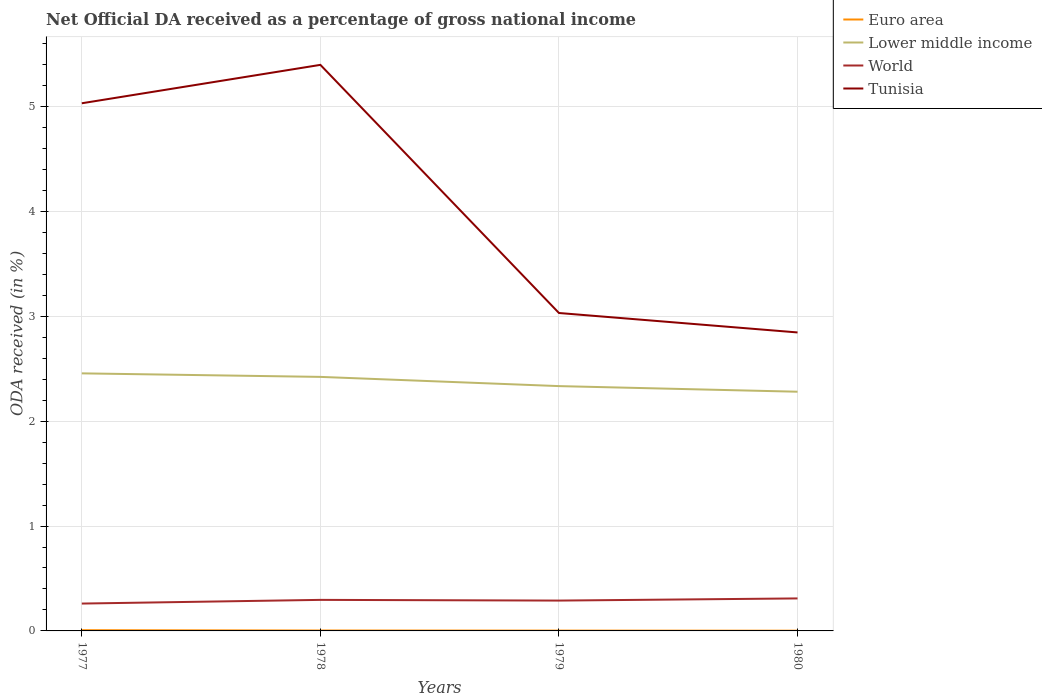Does the line corresponding to Lower middle income intersect with the line corresponding to World?
Your answer should be very brief. No. Is the number of lines equal to the number of legend labels?
Your answer should be very brief. Yes. Across all years, what is the maximum net official DA received in Euro area?
Ensure brevity in your answer.  0. In which year was the net official DA received in Lower middle income maximum?
Offer a terse response. 1980. What is the total net official DA received in Euro area in the graph?
Offer a very short reply. 0. What is the difference between the highest and the second highest net official DA received in Euro area?
Your answer should be very brief. 0. What is the difference between the highest and the lowest net official DA received in Lower middle income?
Offer a very short reply. 2. Is the net official DA received in Tunisia strictly greater than the net official DA received in Euro area over the years?
Ensure brevity in your answer.  No. How many years are there in the graph?
Give a very brief answer. 4. What is the difference between two consecutive major ticks on the Y-axis?
Provide a succinct answer. 1. Does the graph contain any zero values?
Provide a short and direct response. No. How many legend labels are there?
Your answer should be compact. 4. What is the title of the graph?
Provide a short and direct response. Net Official DA received as a percentage of gross national income. Does "Guyana" appear as one of the legend labels in the graph?
Your response must be concise. No. What is the label or title of the Y-axis?
Provide a succinct answer. ODA received (in %). What is the ODA received (in %) of Euro area in 1977?
Make the answer very short. 0.01. What is the ODA received (in %) in Lower middle income in 1977?
Your answer should be very brief. 2.46. What is the ODA received (in %) of World in 1977?
Your answer should be compact. 0.26. What is the ODA received (in %) of Tunisia in 1977?
Your answer should be very brief. 5.03. What is the ODA received (in %) of Euro area in 1978?
Offer a terse response. 0. What is the ODA received (in %) of Lower middle income in 1978?
Your response must be concise. 2.42. What is the ODA received (in %) in World in 1978?
Ensure brevity in your answer.  0.3. What is the ODA received (in %) in Tunisia in 1978?
Ensure brevity in your answer.  5.4. What is the ODA received (in %) in Euro area in 1979?
Make the answer very short. 0. What is the ODA received (in %) in Lower middle income in 1979?
Keep it short and to the point. 2.33. What is the ODA received (in %) in World in 1979?
Ensure brevity in your answer.  0.29. What is the ODA received (in %) of Tunisia in 1979?
Offer a very short reply. 3.03. What is the ODA received (in %) in Euro area in 1980?
Provide a short and direct response. 0. What is the ODA received (in %) of Lower middle income in 1980?
Your response must be concise. 2.28. What is the ODA received (in %) in World in 1980?
Offer a very short reply. 0.31. What is the ODA received (in %) of Tunisia in 1980?
Provide a short and direct response. 2.85. Across all years, what is the maximum ODA received (in %) in Euro area?
Offer a very short reply. 0.01. Across all years, what is the maximum ODA received (in %) of Lower middle income?
Ensure brevity in your answer.  2.46. Across all years, what is the maximum ODA received (in %) in World?
Offer a very short reply. 0.31. Across all years, what is the maximum ODA received (in %) in Tunisia?
Offer a terse response. 5.4. Across all years, what is the minimum ODA received (in %) of Euro area?
Make the answer very short. 0. Across all years, what is the minimum ODA received (in %) in Lower middle income?
Ensure brevity in your answer.  2.28. Across all years, what is the minimum ODA received (in %) in World?
Ensure brevity in your answer.  0.26. Across all years, what is the minimum ODA received (in %) in Tunisia?
Your answer should be very brief. 2.85. What is the total ODA received (in %) of Euro area in the graph?
Your answer should be very brief. 0.02. What is the total ODA received (in %) of Lower middle income in the graph?
Your answer should be very brief. 9.49. What is the total ODA received (in %) in World in the graph?
Make the answer very short. 1.16. What is the total ODA received (in %) in Tunisia in the graph?
Keep it short and to the point. 16.31. What is the difference between the ODA received (in %) of Euro area in 1977 and that in 1978?
Provide a succinct answer. 0. What is the difference between the ODA received (in %) in Lower middle income in 1977 and that in 1978?
Offer a very short reply. 0.03. What is the difference between the ODA received (in %) in World in 1977 and that in 1978?
Your response must be concise. -0.04. What is the difference between the ODA received (in %) of Tunisia in 1977 and that in 1978?
Give a very brief answer. -0.37. What is the difference between the ODA received (in %) of Euro area in 1977 and that in 1979?
Ensure brevity in your answer.  0. What is the difference between the ODA received (in %) in Lower middle income in 1977 and that in 1979?
Offer a very short reply. 0.12. What is the difference between the ODA received (in %) of World in 1977 and that in 1979?
Ensure brevity in your answer.  -0.03. What is the difference between the ODA received (in %) of Tunisia in 1977 and that in 1979?
Provide a succinct answer. 2. What is the difference between the ODA received (in %) in Euro area in 1977 and that in 1980?
Offer a terse response. 0. What is the difference between the ODA received (in %) of Lower middle income in 1977 and that in 1980?
Your answer should be very brief. 0.18. What is the difference between the ODA received (in %) in World in 1977 and that in 1980?
Provide a succinct answer. -0.05. What is the difference between the ODA received (in %) of Tunisia in 1977 and that in 1980?
Your response must be concise. 2.19. What is the difference between the ODA received (in %) in Euro area in 1978 and that in 1979?
Ensure brevity in your answer.  0. What is the difference between the ODA received (in %) of Lower middle income in 1978 and that in 1979?
Your answer should be very brief. 0.09. What is the difference between the ODA received (in %) in World in 1978 and that in 1979?
Offer a terse response. 0.01. What is the difference between the ODA received (in %) of Tunisia in 1978 and that in 1979?
Keep it short and to the point. 2.37. What is the difference between the ODA received (in %) of Euro area in 1978 and that in 1980?
Offer a very short reply. 0. What is the difference between the ODA received (in %) in Lower middle income in 1978 and that in 1980?
Ensure brevity in your answer.  0.14. What is the difference between the ODA received (in %) in World in 1978 and that in 1980?
Your response must be concise. -0.01. What is the difference between the ODA received (in %) in Tunisia in 1978 and that in 1980?
Your answer should be compact. 2.55. What is the difference between the ODA received (in %) of Euro area in 1979 and that in 1980?
Your answer should be compact. 0. What is the difference between the ODA received (in %) of Lower middle income in 1979 and that in 1980?
Provide a short and direct response. 0.05. What is the difference between the ODA received (in %) in World in 1979 and that in 1980?
Provide a succinct answer. -0.02. What is the difference between the ODA received (in %) in Tunisia in 1979 and that in 1980?
Provide a short and direct response. 0.19. What is the difference between the ODA received (in %) of Euro area in 1977 and the ODA received (in %) of Lower middle income in 1978?
Provide a succinct answer. -2.42. What is the difference between the ODA received (in %) in Euro area in 1977 and the ODA received (in %) in World in 1978?
Offer a very short reply. -0.29. What is the difference between the ODA received (in %) in Euro area in 1977 and the ODA received (in %) in Tunisia in 1978?
Give a very brief answer. -5.39. What is the difference between the ODA received (in %) in Lower middle income in 1977 and the ODA received (in %) in World in 1978?
Make the answer very short. 2.16. What is the difference between the ODA received (in %) in Lower middle income in 1977 and the ODA received (in %) in Tunisia in 1978?
Offer a terse response. -2.94. What is the difference between the ODA received (in %) of World in 1977 and the ODA received (in %) of Tunisia in 1978?
Keep it short and to the point. -5.14. What is the difference between the ODA received (in %) of Euro area in 1977 and the ODA received (in %) of Lower middle income in 1979?
Your answer should be compact. -2.33. What is the difference between the ODA received (in %) of Euro area in 1977 and the ODA received (in %) of World in 1979?
Provide a short and direct response. -0.28. What is the difference between the ODA received (in %) in Euro area in 1977 and the ODA received (in %) in Tunisia in 1979?
Give a very brief answer. -3.02. What is the difference between the ODA received (in %) in Lower middle income in 1977 and the ODA received (in %) in World in 1979?
Your answer should be very brief. 2.17. What is the difference between the ODA received (in %) in Lower middle income in 1977 and the ODA received (in %) in Tunisia in 1979?
Provide a short and direct response. -0.58. What is the difference between the ODA received (in %) in World in 1977 and the ODA received (in %) in Tunisia in 1979?
Ensure brevity in your answer.  -2.77. What is the difference between the ODA received (in %) of Euro area in 1977 and the ODA received (in %) of Lower middle income in 1980?
Ensure brevity in your answer.  -2.27. What is the difference between the ODA received (in %) of Euro area in 1977 and the ODA received (in %) of World in 1980?
Offer a very short reply. -0.3. What is the difference between the ODA received (in %) in Euro area in 1977 and the ODA received (in %) in Tunisia in 1980?
Make the answer very short. -2.84. What is the difference between the ODA received (in %) of Lower middle income in 1977 and the ODA received (in %) of World in 1980?
Offer a terse response. 2.15. What is the difference between the ODA received (in %) in Lower middle income in 1977 and the ODA received (in %) in Tunisia in 1980?
Ensure brevity in your answer.  -0.39. What is the difference between the ODA received (in %) of World in 1977 and the ODA received (in %) of Tunisia in 1980?
Make the answer very short. -2.59. What is the difference between the ODA received (in %) in Euro area in 1978 and the ODA received (in %) in Lower middle income in 1979?
Offer a very short reply. -2.33. What is the difference between the ODA received (in %) of Euro area in 1978 and the ODA received (in %) of World in 1979?
Give a very brief answer. -0.29. What is the difference between the ODA received (in %) of Euro area in 1978 and the ODA received (in %) of Tunisia in 1979?
Give a very brief answer. -3.03. What is the difference between the ODA received (in %) in Lower middle income in 1978 and the ODA received (in %) in World in 1979?
Ensure brevity in your answer.  2.13. What is the difference between the ODA received (in %) in Lower middle income in 1978 and the ODA received (in %) in Tunisia in 1979?
Your response must be concise. -0.61. What is the difference between the ODA received (in %) in World in 1978 and the ODA received (in %) in Tunisia in 1979?
Your answer should be very brief. -2.74. What is the difference between the ODA received (in %) in Euro area in 1978 and the ODA received (in %) in Lower middle income in 1980?
Offer a terse response. -2.28. What is the difference between the ODA received (in %) in Euro area in 1978 and the ODA received (in %) in World in 1980?
Your answer should be compact. -0.31. What is the difference between the ODA received (in %) of Euro area in 1978 and the ODA received (in %) of Tunisia in 1980?
Give a very brief answer. -2.84. What is the difference between the ODA received (in %) of Lower middle income in 1978 and the ODA received (in %) of World in 1980?
Provide a succinct answer. 2.11. What is the difference between the ODA received (in %) of Lower middle income in 1978 and the ODA received (in %) of Tunisia in 1980?
Your answer should be compact. -0.42. What is the difference between the ODA received (in %) in World in 1978 and the ODA received (in %) in Tunisia in 1980?
Keep it short and to the point. -2.55. What is the difference between the ODA received (in %) of Euro area in 1979 and the ODA received (in %) of Lower middle income in 1980?
Keep it short and to the point. -2.28. What is the difference between the ODA received (in %) of Euro area in 1979 and the ODA received (in %) of World in 1980?
Ensure brevity in your answer.  -0.31. What is the difference between the ODA received (in %) of Euro area in 1979 and the ODA received (in %) of Tunisia in 1980?
Keep it short and to the point. -2.84. What is the difference between the ODA received (in %) of Lower middle income in 1979 and the ODA received (in %) of World in 1980?
Offer a terse response. 2.02. What is the difference between the ODA received (in %) of Lower middle income in 1979 and the ODA received (in %) of Tunisia in 1980?
Ensure brevity in your answer.  -0.51. What is the difference between the ODA received (in %) of World in 1979 and the ODA received (in %) of Tunisia in 1980?
Make the answer very short. -2.56. What is the average ODA received (in %) of Euro area per year?
Your answer should be very brief. 0. What is the average ODA received (in %) of Lower middle income per year?
Ensure brevity in your answer.  2.37. What is the average ODA received (in %) of World per year?
Give a very brief answer. 0.29. What is the average ODA received (in %) in Tunisia per year?
Provide a short and direct response. 4.08. In the year 1977, what is the difference between the ODA received (in %) in Euro area and ODA received (in %) in Lower middle income?
Your answer should be compact. -2.45. In the year 1977, what is the difference between the ODA received (in %) of Euro area and ODA received (in %) of World?
Give a very brief answer. -0.25. In the year 1977, what is the difference between the ODA received (in %) in Euro area and ODA received (in %) in Tunisia?
Your answer should be compact. -5.02. In the year 1977, what is the difference between the ODA received (in %) of Lower middle income and ODA received (in %) of World?
Ensure brevity in your answer.  2.2. In the year 1977, what is the difference between the ODA received (in %) in Lower middle income and ODA received (in %) in Tunisia?
Provide a succinct answer. -2.58. In the year 1977, what is the difference between the ODA received (in %) in World and ODA received (in %) in Tunisia?
Your response must be concise. -4.77. In the year 1978, what is the difference between the ODA received (in %) in Euro area and ODA received (in %) in Lower middle income?
Provide a succinct answer. -2.42. In the year 1978, what is the difference between the ODA received (in %) in Euro area and ODA received (in %) in World?
Make the answer very short. -0.29. In the year 1978, what is the difference between the ODA received (in %) of Euro area and ODA received (in %) of Tunisia?
Provide a short and direct response. -5.39. In the year 1978, what is the difference between the ODA received (in %) of Lower middle income and ODA received (in %) of World?
Provide a succinct answer. 2.13. In the year 1978, what is the difference between the ODA received (in %) of Lower middle income and ODA received (in %) of Tunisia?
Ensure brevity in your answer.  -2.98. In the year 1978, what is the difference between the ODA received (in %) in World and ODA received (in %) in Tunisia?
Offer a terse response. -5.1. In the year 1979, what is the difference between the ODA received (in %) in Euro area and ODA received (in %) in Lower middle income?
Provide a short and direct response. -2.33. In the year 1979, what is the difference between the ODA received (in %) in Euro area and ODA received (in %) in World?
Give a very brief answer. -0.29. In the year 1979, what is the difference between the ODA received (in %) of Euro area and ODA received (in %) of Tunisia?
Your answer should be compact. -3.03. In the year 1979, what is the difference between the ODA received (in %) in Lower middle income and ODA received (in %) in World?
Your answer should be very brief. 2.05. In the year 1979, what is the difference between the ODA received (in %) in Lower middle income and ODA received (in %) in Tunisia?
Your answer should be very brief. -0.7. In the year 1979, what is the difference between the ODA received (in %) in World and ODA received (in %) in Tunisia?
Give a very brief answer. -2.74. In the year 1980, what is the difference between the ODA received (in %) in Euro area and ODA received (in %) in Lower middle income?
Your answer should be compact. -2.28. In the year 1980, what is the difference between the ODA received (in %) in Euro area and ODA received (in %) in World?
Your answer should be very brief. -0.31. In the year 1980, what is the difference between the ODA received (in %) of Euro area and ODA received (in %) of Tunisia?
Make the answer very short. -2.84. In the year 1980, what is the difference between the ODA received (in %) of Lower middle income and ODA received (in %) of World?
Provide a succinct answer. 1.97. In the year 1980, what is the difference between the ODA received (in %) in Lower middle income and ODA received (in %) in Tunisia?
Offer a very short reply. -0.57. In the year 1980, what is the difference between the ODA received (in %) of World and ODA received (in %) of Tunisia?
Offer a very short reply. -2.54. What is the ratio of the ODA received (in %) of Euro area in 1977 to that in 1978?
Your answer should be compact. 1.77. What is the ratio of the ODA received (in %) of Lower middle income in 1977 to that in 1978?
Provide a short and direct response. 1.01. What is the ratio of the ODA received (in %) in World in 1977 to that in 1978?
Your answer should be very brief. 0.88. What is the ratio of the ODA received (in %) of Tunisia in 1977 to that in 1978?
Provide a succinct answer. 0.93. What is the ratio of the ODA received (in %) of Euro area in 1977 to that in 1979?
Offer a very short reply. 2.29. What is the ratio of the ODA received (in %) in Lower middle income in 1977 to that in 1979?
Ensure brevity in your answer.  1.05. What is the ratio of the ODA received (in %) in World in 1977 to that in 1979?
Your answer should be compact. 0.9. What is the ratio of the ODA received (in %) of Tunisia in 1977 to that in 1979?
Your answer should be compact. 1.66. What is the ratio of the ODA received (in %) in Euro area in 1977 to that in 1980?
Offer a terse response. 3.06. What is the ratio of the ODA received (in %) of Lower middle income in 1977 to that in 1980?
Offer a terse response. 1.08. What is the ratio of the ODA received (in %) in World in 1977 to that in 1980?
Ensure brevity in your answer.  0.84. What is the ratio of the ODA received (in %) of Tunisia in 1977 to that in 1980?
Offer a very short reply. 1.77. What is the ratio of the ODA received (in %) in Euro area in 1978 to that in 1979?
Give a very brief answer. 1.29. What is the ratio of the ODA received (in %) in Lower middle income in 1978 to that in 1979?
Your answer should be very brief. 1.04. What is the ratio of the ODA received (in %) in World in 1978 to that in 1979?
Provide a short and direct response. 1.02. What is the ratio of the ODA received (in %) in Tunisia in 1978 to that in 1979?
Your answer should be compact. 1.78. What is the ratio of the ODA received (in %) of Euro area in 1978 to that in 1980?
Keep it short and to the point. 1.72. What is the ratio of the ODA received (in %) of Lower middle income in 1978 to that in 1980?
Offer a terse response. 1.06. What is the ratio of the ODA received (in %) of World in 1978 to that in 1980?
Make the answer very short. 0.96. What is the ratio of the ODA received (in %) in Tunisia in 1978 to that in 1980?
Offer a very short reply. 1.9. What is the ratio of the ODA received (in %) in Euro area in 1979 to that in 1980?
Offer a terse response. 1.33. What is the ratio of the ODA received (in %) of Lower middle income in 1979 to that in 1980?
Ensure brevity in your answer.  1.02. What is the ratio of the ODA received (in %) in World in 1979 to that in 1980?
Your answer should be very brief. 0.93. What is the ratio of the ODA received (in %) in Tunisia in 1979 to that in 1980?
Ensure brevity in your answer.  1.07. What is the difference between the highest and the second highest ODA received (in %) in Euro area?
Provide a succinct answer. 0. What is the difference between the highest and the second highest ODA received (in %) of Lower middle income?
Ensure brevity in your answer.  0.03. What is the difference between the highest and the second highest ODA received (in %) in World?
Give a very brief answer. 0.01. What is the difference between the highest and the second highest ODA received (in %) in Tunisia?
Your response must be concise. 0.37. What is the difference between the highest and the lowest ODA received (in %) in Euro area?
Provide a succinct answer. 0. What is the difference between the highest and the lowest ODA received (in %) of Lower middle income?
Your answer should be compact. 0.18. What is the difference between the highest and the lowest ODA received (in %) in World?
Ensure brevity in your answer.  0.05. What is the difference between the highest and the lowest ODA received (in %) of Tunisia?
Make the answer very short. 2.55. 